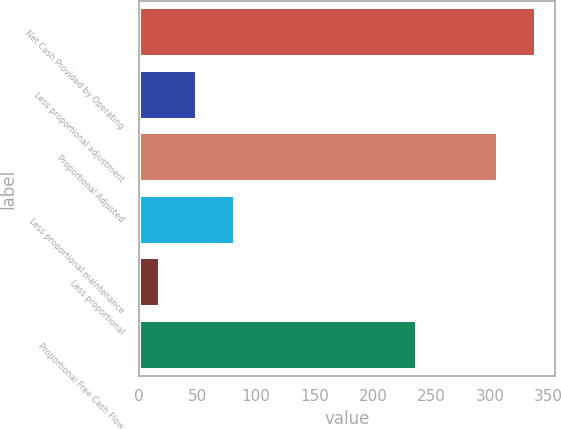<chart> <loc_0><loc_0><loc_500><loc_500><bar_chart><fcel>Net Cash Provided by Operating<fcel>Less proportional adjustment<fcel>Proportional Adjusted<fcel>Less proportional maintenance<fcel>Less proportional<fcel>Proportional Free Cash Flow<nl><fcel>339.1<fcel>50.1<fcel>307<fcel>82.2<fcel>18<fcel>238<nl></chart> 